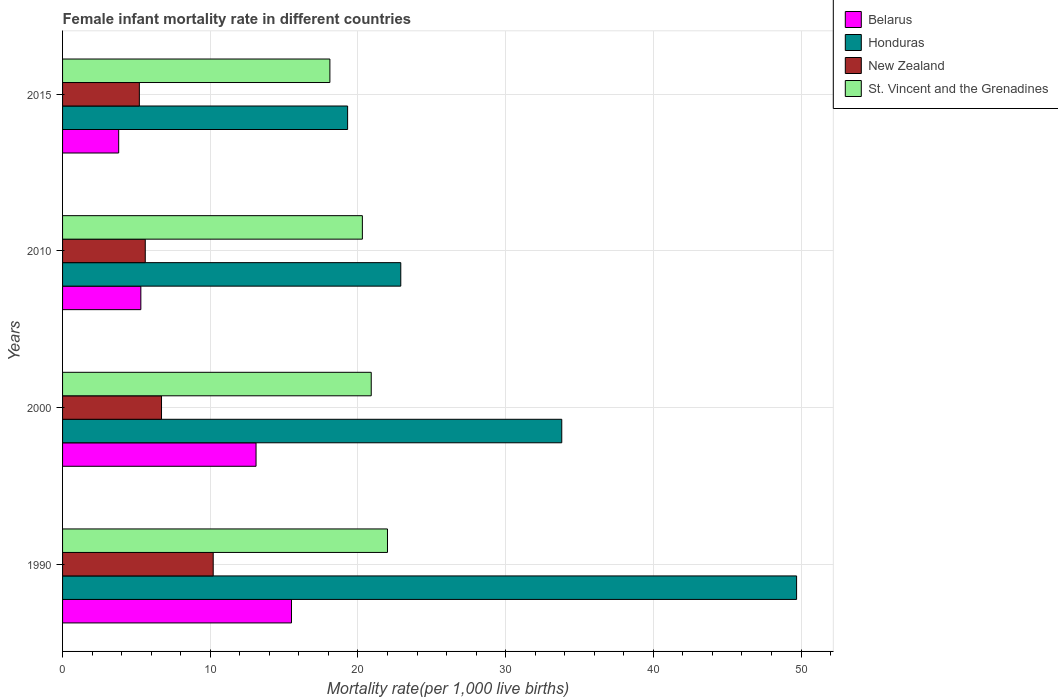How many groups of bars are there?
Provide a short and direct response. 4. Are the number of bars per tick equal to the number of legend labels?
Offer a terse response. Yes. What is the female infant mortality rate in St. Vincent and the Grenadines in 2000?
Offer a terse response. 20.9. Across all years, what is the maximum female infant mortality rate in Belarus?
Give a very brief answer. 15.5. Across all years, what is the minimum female infant mortality rate in New Zealand?
Make the answer very short. 5.2. In which year was the female infant mortality rate in Honduras maximum?
Offer a very short reply. 1990. In which year was the female infant mortality rate in St. Vincent and the Grenadines minimum?
Provide a succinct answer. 2015. What is the total female infant mortality rate in St. Vincent and the Grenadines in the graph?
Keep it short and to the point. 81.3. What is the difference between the female infant mortality rate in Belarus in 1990 and that in 2010?
Offer a very short reply. 10.2. What is the difference between the female infant mortality rate in Honduras in 1990 and the female infant mortality rate in Belarus in 2015?
Your answer should be compact. 45.9. What is the average female infant mortality rate in St. Vincent and the Grenadines per year?
Your response must be concise. 20.33. What is the ratio of the female infant mortality rate in Honduras in 2010 to that in 2015?
Offer a terse response. 1.19. Is the female infant mortality rate in St. Vincent and the Grenadines in 2000 less than that in 2015?
Offer a very short reply. No. What is the difference between the highest and the second highest female infant mortality rate in Belarus?
Keep it short and to the point. 2.4. What is the difference between the highest and the lowest female infant mortality rate in Belarus?
Keep it short and to the point. 11.7. In how many years, is the female infant mortality rate in New Zealand greater than the average female infant mortality rate in New Zealand taken over all years?
Offer a very short reply. 1. Is it the case that in every year, the sum of the female infant mortality rate in St. Vincent and the Grenadines and female infant mortality rate in New Zealand is greater than the sum of female infant mortality rate in Honduras and female infant mortality rate in Belarus?
Your response must be concise. Yes. What does the 4th bar from the top in 1990 represents?
Offer a terse response. Belarus. What does the 4th bar from the bottom in 1990 represents?
Your answer should be compact. St. Vincent and the Grenadines. Are all the bars in the graph horizontal?
Make the answer very short. Yes. How many years are there in the graph?
Your answer should be very brief. 4. Are the values on the major ticks of X-axis written in scientific E-notation?
Provide a succinct answer. No. Does the graph contain any zero values?
Ensure brevity in your answer.  No. Does the graph contain grids?
Keep it short and to the point. Yes. Where does the legend appear in the graph?
Your response must be concise. Top right. What is the title of the graph?
Provide a short and direct response. Female infant mortality rate in different countries. Does "Botswana" appear as one of the legend labels in the graph?
Offer a very short reply. No. What is the label or title of the X-axis?
Make the answer very short. Mortality rate(per 1,0 live births). What is the label or title of the Y-axis?
Ensure brevity in your answer.  Years. What is the Mortality rate(per 1,000 live births) in Honduras in 1990?
Your answer should be compact. 49.7. What is the Mortality rate(per 1,000 live births) in New Zealand in 1990?
Offer a very short reply. 10.2. What is the Mortality rate(per 1,000 live births) of Honduras in 2000?
Your answer should be compact. 33.8. What is the Mortality rate(per 1,000 live births) in New Zealand in 2000?
Keep it short and to the point. 6.7. What is the Mortality rate(per 1,000 live births) in St. Vincent and the Grenadines in 2000?
Provide a short and direct response. 20.9. What is the Mortality rate(per 1,000 live births) of Honduras in 2010?
Provide a short and direct response. 22.9. What is the Mortality rate(per 1,000 live births) of New Zealand in 2010?
Your answer should be very brief. 5.6. What is the Mortality rate(per 1,000 live births) of St. Vincent and the Grenadines in 2010?
Offer a terse response. 20.3. What is the Mortality rate(per 1,000 live births) in Belarus in 2015?
Provide a short and direct response. 3.8. What is the Mortality rate(per 1,000 live births) of Honduras in 2015?
Your answer should be compact. 19.3. What is the Mortality rate(per 1,000 live births) of St. Vincent and the Grenadines in 2015?
Offer a very short reply. 18.1. Across all years, what is the maximum Mortality rate(per 1,000 live births) of Belarus?
Your answer should be very brief. 15.5. Across all years, what is the maximum Mortality rate(per 1,000 live births) of Honduras?
Your response must be concise. 49.7. Across all years, what is the maximum Mortality rate(per 1,000 live births) of New Zealand?
Keep it short and to the point. 10.2. Across all years, what is the minimum Mortality rate(per 1,000 live births) of Honduras?
Ensure brevity in your answer.  19.3. What is the total Mortality rate(per 1,000 live births) of Belarus in the graph?
Provide a succinct answer. 37.7. What is the total Mortality rate(per 1,000 live births) in Honduras in the graph?
Offer a terse response. 125.7. What is the total Mortality rate(per 1,000 live births) in New Zealand in the graph?
Your answer should be very brief. 27.7. What is the total Mortality rate(per 1,000 live births) in St. Vincent and the Grenadines in the graph?
Provide a short and direct response. 81.3. What is the difference between the Mortality rate(per 1,000 live births) of Honduras in 1990 and that in 2000?
Your answer should be very brief. 15.9. What is the difference between the Mortality rate(per 1,000 live births) of Honduras in 1990 and that in 2010?
Your answer should be very brief. 26.8. What is the difference between the Mortality rate(per 1,000 live births) in New Zealand in 1990 and that in 2010?
Offer a very short reply. 4.6. What is the difference between the Mortality rate(per 1,000 live births) in St. Vincent and the Grenadines in 1990 and that in 2010?
Your answer should be compact. 1.7. What is the difference between the Mortality rate(per 1,000 live births) of Belarus in 1990 and that in 2015?
Your answer should be compact. 11.7. What is the difference between the Mortality rate(per 1,000 live births) of Honduras in 1990 and that in 2015?
Provide a succinct answer. 30.4. What is the difference between the Mortality rate(per 1,000 live births) in Belarus in 2000 and that in 2010?
Your answer should be very brief. 7.8. What is the difference between the Mortality rate(per 1,000 live births) in Honduras in 2000 and that in 2010?
Keep it short and to the point. 10.9. What is the difference between the Mortality rate(per 1,000 live births) in New Zealand in 2000 and that in 2010?
Make the answer very short. 1.1. What is the difference between the Mortality rate(per 1,000 live births) in Belarus in 2000 and that in 2015?
Offer a very short reply. 9.3. What is the difference between the Mortality rate(per 1,000 live births) in Honduras in 2000 and that in 2015?
Make the answer very short. 14.5. What is the difference between the Mortality rate(per 1,000 live births) of New Zealand in 2000 and that in 2015?
Your response must be concise. 1.5. What is the difference between the Mortality rate(per 1,000 live births) in Belarus in 2010 and that in 2015?
Your answer should be very brief. 1.5. What is the difference between the Mortality rate(per 1,000 live births) in Honduras in 2010 and that in 2015?
Your answer should be compact. 3.6. What is the difference between the Mortality rate(per 1,000 live births) in New Zealand in 2010 and that in 2015?
Your answer should be compact. 0.4. What is the difference between the Mortality rate(per 1,000 live births) in St. Vincent and the Grenadines in 2010 and that in 2015?
Make the answer very short. 2.2. What is the difference between the Mortality rate(per 1,000 live births) of Belarus in 1990 and the Mortality rate(per 1,000 live births) of Honduras in 2000?
Ensure brevity in your answer.  -18.3. What is the difference between the Mortality rate(per 1,000 live births) of Belarus in 1990 and the Mortality rate(per 1,000 live births) of New Zealand in 2000?
Your answer should be very brief. 8.8. What is the difference between the Mortality rate(per 1,000 live births) of Belarus in 1990 and the Mortality rate(per 1,000 live births) of St. Vincent and the Grenadines in 2000?
Give a very brief answer. -5.4. What is the difference between the Mortality rate(per 1,000 live births) of Honduras in 1990 and the Mortality rate(per 1,000 live births) of St. Vincent and the Grenadines in 2000?
Your answer should be compact. 28.8. What is the difference between the Mortality rate(per 1,000 live births) of Belarus in 1990 and the Mortality rate(per 1,000 live births) of Honduras in 2010?
Make the answer very short. -7.4. What is the difference between the Mortality rate(per 1,000 live births) in Belarus in 1990 and the Mortality rate(per 1,000 live births) in New Zealand in 2010?
Your response must be concise. 9.9. What is the difference between the Mortality rate(per 1,000 live births) in Honduras in 1990 and the Mortality rate(per 1,000 live births) in New Zealand in 2010?
Give a very brief answer. 44.1. What is the difference between the Mortality rate(per 1,000 live births) of Honduras in 1990 and the Mortality rate(per 1,000 live births) of St. Vincent and the Grenadines in 2010?
Offer a very short reply. 29.4. What is the difference between the Mortality rate(per 1,000 live births) of New Zealand in 1990 and the Mortality rate(per 1,000 live births) of St. Vincent and the Grenadines in 2010?
Provide a succinct answer. -10.1. What is the difference between the Mortality rate(per 1,000 live births) in Belarus in 1990 and the Mortality rate(per 1,000 live births) in Honduras in 2015?
Keep it short and to the point. -3.8. What is the difference between the Mortality rate(per 1,000 live births) in Honduras in 1990 and the Mortality rate(per 1,000 live births) in New Zealand in 2015?
Ensure brevity in your answer.  44.5. What is the difference between the Mortality rate(per 1,000 live births) of Honduras in 1990 and the Mortality rate(per 1,000 live births) of St. Vincent and the Grenadines in 2015?
Provide a short and direct response. 31.6. What is the difference between the Mortality rate(per 1,000 live births) in Honduras in 2000 and the Mortality rate(per 1,000 live births) in New Zealand in 2010?
Provide a short and direct response. 28.2. What is the difference between the Mortality rate(per 1,000 live births) in New Zealand in 2000 and the Mortality rate(per 1,000 live births) in St. Vincent and the Grenadines in 2010?
Provide a succinct answer. -13.6. What is the difference between the Mortality rate(per 1,000 live births) of Belarus in 2000 and the Mortality rate(per 1,000 live births) of Honduras in 2015?
Your answer should be compact. -6.2. What is the difference between the Mortality rate(per 1,000 live births) in Honduras in 2000 and the Mortality rate(per 1,000 live births) in New Zealand in 2015?
Provide a succinct answer. 28.6. What is the difference between the Mortality rate(per 1,000 live births) of Belarus in 2010 and the Mortality rate(per 1,000 live births) of Honduras in 2015?
Make the answer very short. -14. What is the difference between the Mortality rate(per 1,000 live births) of Belarus in 2010 and the Mortality rate(per 1,000 live births) of St. Vincent and the Grenadines in 2015?
Ensure brevity in your answer.  -12.8. What is the difference between the Mortality rate(per 1,000 live births) in Honduras in 2010 and the Mortality rate(per 1,000 live births) in St. Vincent and the Grenadines in 2015?
Keep it short and to the point. 4.8. What is the difference between the Mortality rate(per 1,000 live births) of New Zealand in 2010 and the Mortality rate(per 1,000 live births) of St. Vincent and the Grenadines in 2015?
Your answer should be very brief. -12.5. What is the average Mortality rate(per 1,000 live births) in Belarus per year?
Offer a terse response. 9.43. What is the average Mortality rate(per 1,000 live births) in Honduras per year?
Offer a very short reply. 31.43. What is the average Mortality rate(per 1,000 live births) of New Zealand per year?
Offer a terse response. 6.92. What is the average Mortality rate(per 1,000 live births) of St. Vincent and the Grenadines per year?
Make the answer very short. 20.32. In the year 1990, what is the difference between the Mortality rate(per 1,000 live births) of Belarus and Mortality rate(per 1,000 live births) of Honduras?
Keep it short and to the point. -34.2. In the year 1990, what is the difference between the Mortality rate(per 1,000 live births) in Belarus and Mortality rate(per 1,000 live births) in New Zealand?
Ensure brevity in your answer.  5.3. In the year 1990, what is the difference between the Mortality rate(per 1,000 live births) in Honduras and Mortality rate(per 1,000 live births) in New Zealand?
Provide a short and direct response. 39.5. In the year 1990, what is the difference between the Mortality rate(per 1,000 live births) of Honduras and Mortality rate(per 1,000 live births) of St. Vincent and the Grenadines?
Give a very brief answer. 27.7. In the year 2000, what is the difference between the Mortality rate(per 1,000 live births) in Belarus and Mortality rate(per 1,000 live births) in Honduras?
Provide a short and direct response. -20.7. In the year 2000, what is the difference between the Mortality rate(per 1,000 live births) in Honduras and Mortality rate(per 1,000 live births) in New Zealand?
Provide a succinct answer. 27.1. In the year 2000, what is the difference between the Mortality rate(per 1,000 live births) in New Zealand and Mortality rate(per 1,000 live births) in St. Vincent and the Grenadines?
Offer a terse response. -14.2. In the year 2010, what is the difference between the Mortality rate(per 1,000 live births) of Belarus and Mortality rate(per 1,000 live births) of Honduras?
Your answer should be very brief. -17.6. In the year 2010, what is the difference between the Mortality rate(per 1,000 live births) of Belarus and Mortality rate(per 1,000 live births) of New Zealand?
Your answer should be very brief. -0.3. In the year 2010, what is the difference between the Mortality rate(per 1,000 live births) of Belarus and Mortality rate(per 1,000 live births) of St. Vincent and the Grenadines?
Provide a succinct answer. -15. In the year 2010, what is the difference between the Mortality rate(per 1,000 live births) in New Zealand and Mortality rate(per 1,000 live births) in St. Vincent and the Grenadines?
Offer a very short reply. -14.7. In the year 2015, what is the difference between the Mortality rate(per 1,000 live births) of Belarus and Mortality rate(per 1,000 live births) of Honduras?
Provide a short and direct response. -15.5. In the year 2015, what is the difference between the Mortality rate(per 1,000 live births) of Belarus and Mortality rate(per 1,000 live births) of New Zealand?
Offer a very short reply. -1.4. In the year 2015, what is the difference between the Mortality rate(per 1,000 live births) of Belarus and Mortality rate(per 1,000 live births) of St. Vincent and the Grenadines?
Provide a short and direct response. -14.3. What is the ratio of the Mortality rate(per 1,000 live births) in Belarus in 1990 to that in 2000?
Offer a very short reply. 1.18. What is the ratio of the Mortality rate(per 1,000 live births) of Honduras in 1990 to that in 2000?
Provide a succinct answer. 1.47. What is the ratio of the Mortality rate(per 1,000 live births) in New Zealand in 1990 to that in 2000?
Give a very brief answer. 1.52. What is the ratio of the Mortality rate(per 1,000 live births) in St. Vincent and the Grenadines in 1990 to that in 2000?
Provide a succinct answer. 1.05. What is the ratio of the Mortality rate(per 1,000 live births) of Belarus in 1990 to that in 2010?
Keep it short and to the point. 2.92. What is the ratio of the Mortality rate(per 1,000 live births) in Honduras in 1990 to that in 2010?
Your answer should be very brief. 2.17. What is the ratio of the Mortality rate(per 1,000 live births) of New Zealand in 1990 to that in 2010?
Keep it short and to the point. 1.82. What is the ratio of the Mortality rate(per 1,000 live births) in St. Vincent and the Grenadines in 1990 to that in 2010?
Your response must be concise. 1.08. What is the ratio of the Mortality rate(per 1,000 live births) in Belarus in 1990 to that in 2015?
Provide a succinct answer. 4.08. What is the ratio of the Mortality rate(per 1,000 live births) in Honduras in 1990 to that in 2015?
Give a very brief answer. 2.58. What is the ratio of the Mortality rate(per 1,000 live births) in New Zealand in 1990 to that in 2015?
Keep it short and to the point. 1.96. What is the ratio of the Mortality rate(per 1,000 live births) in St. Vincent and the Grenadines in 1990 to that in 2015?
Your answer should be very brief. 1.22. What is the ratio of the Mortality rate(per 1,000 live births) in Belarus in 2000 to that in 2010?
Offer a terse response. 2.47. What is the ratio of the Mortality rate(per 1,000 live births) of Honduras in 2000 to that in 2010?
Offer a terse response. 1.48. What is the ratio of the Mortality rate(per 1,000 live births) of New Zealand in 2000 to that in 2010?
Make the answer very short. 1.2. What is the ratio of the Mortality rate(per 1,000 live births) of St. Vincent and the Grenadines in 2000 to that in 2010?
Give a very brief answer. 1.03. What is the ratio of the Mortality rate(per 1,000 live births) of Belarus in 2000 to that in 2015?
Your answer should be very brief. 3.45. What is the ratio of the Mortality rate(per 1,000 live births) of Honduras in 2000 to that in 2015?
Give a very brief answer. 1.75. What is the ratio of the Mortality rate(per 1,000 live births) in New Zealand in 2000 to that in 2015?
Keep it short and to the point. 1.29. What is the ratio of the Mortality rate(per 1,000 live births) of St. Vincent and the Grenadines in 2000 to that in 2015?
Ensure brevity in your answer.  1.15. What is the ratio of the Mortality rate(per 1,000 live births) of Belarus in 2010 to that in 2015?
Make the answer very short. 1.39. What is the ratio of the Mortality rate(per 1,000 live births) of Honduras in 2010 to that in 2015?
Give a very brief answer. 1.19. What is the ratio of the Mortality rate(per 1,000 live births) in St. Vincent and the Grenadines in 2010 to that in 2015?
Your answer should be compact. 1.12. What is the difference between the highest and the second highest Mortality rate(per 1,000 live births) in Honduras?
Give a very brief answer. 15.9. What is the difference between the highest and the lowest Mortality rate(per 1,000 live births) in Belarus?
Provide a succinct answer. 11.7. What is the difference between the highest and the lowest Mortality rate(per 1,000 live births) of Honduras?
Provide a succinct answer. 30.4. 